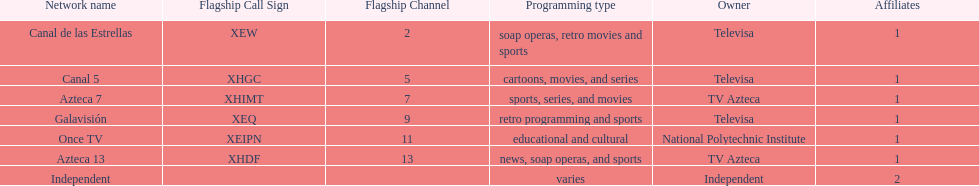What is the number of networks that are owned by televisa? 3. 